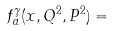Convert formula to latex. <formula><loc_0><loc_0><loc_500><loc_500>f _ { a } ^ { \gamma } ( x , Q ^ { 2 } , P ^ { 2 } ) =</formula> 